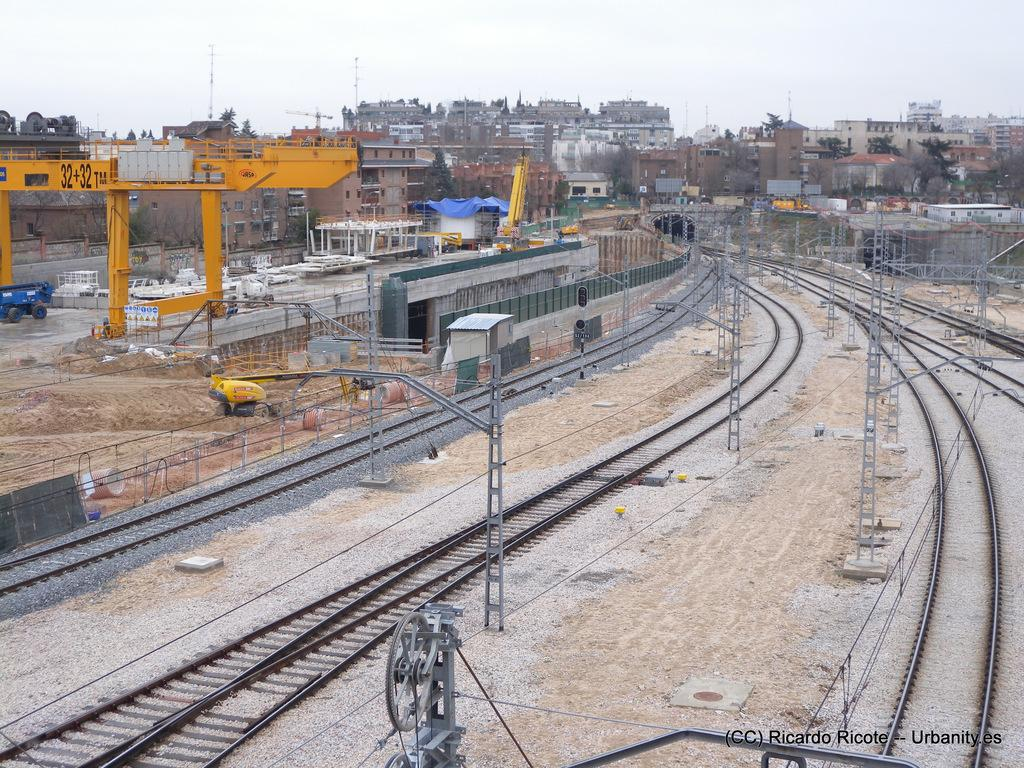<image>
Create a compact narrative representing the image presented. A rail yard has a yellow piece of equipment with 32+32 printed on it. 